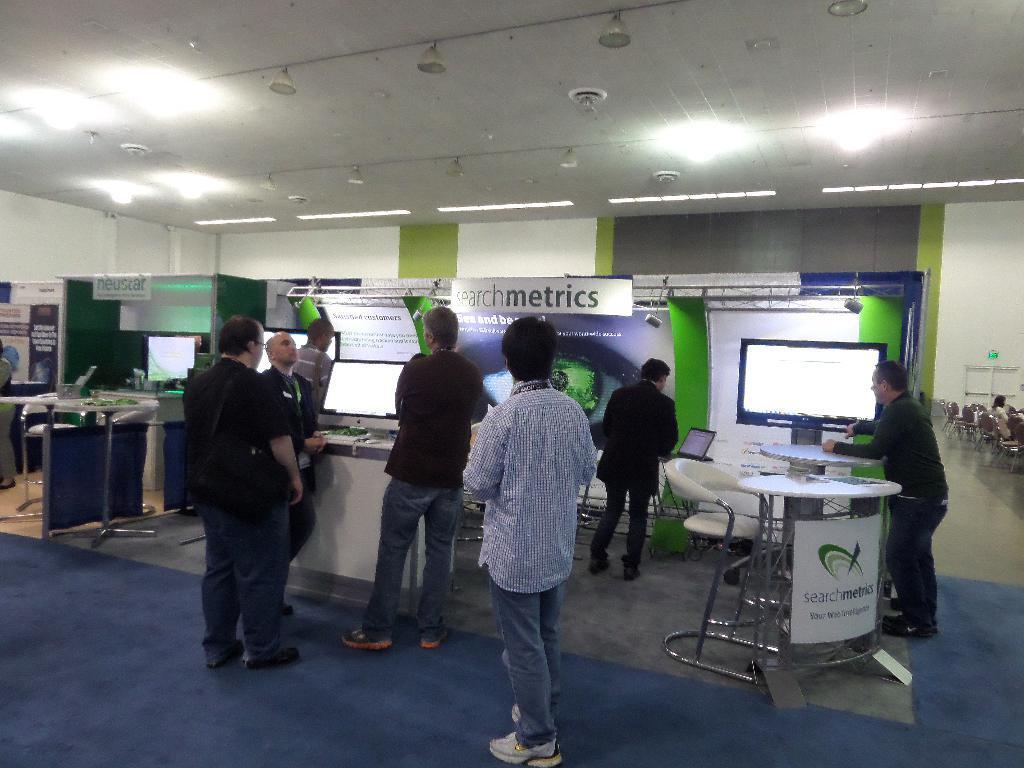Could you give a brief overview of what you see in this image? In this image there are a few people standing in front of stalls, on the stalls there are banners and name boards, in front of the stalls there are banners,tables and chairs, on the tables there are laptops and computers, on the right side of the image there is a woman sitting in chair, beside the women there are empty chairs, beside the chairs there is a door, on top of the door there is an exit sign on the wall, behind the stalls there is a wall, on top of the roof there are lamps. 